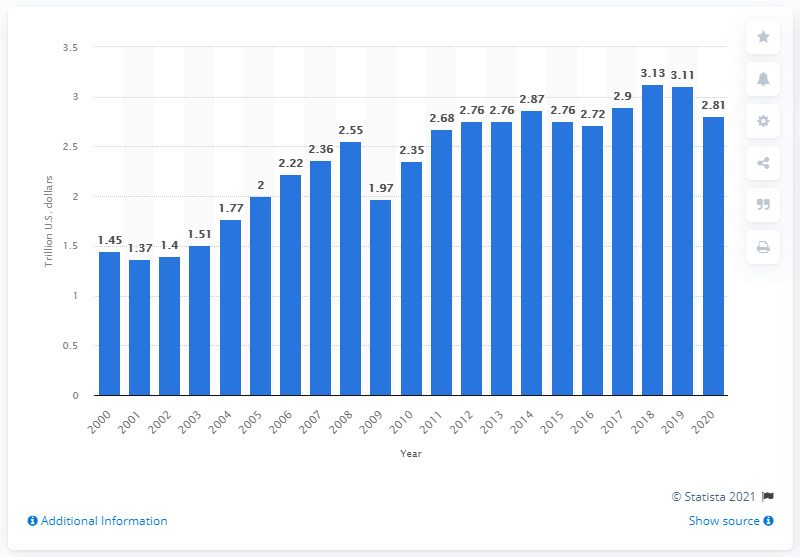Outline some significant characteristics in this image. In 2020, the total value of international U.S. imports of goods and services was 2.81 trillion dollars. 